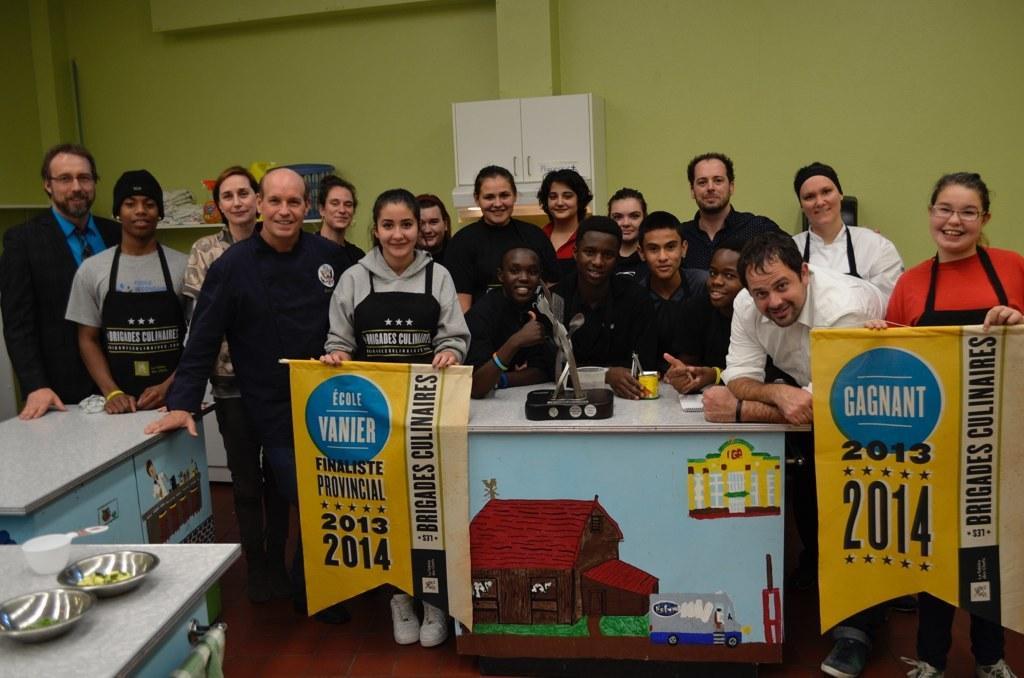Could you give a brief overview of what you see in this image? In this image there are people on the floor. Left side a woman is holding the banner. Beside her there is a table having few objects. Right side there is a woman holding a banner. Left side there are tables on the floor. Left bottom there is a table having bowls and a cup. Background there is a wall having a cupboard attached to it. Left side there are few objects on the shelf. 